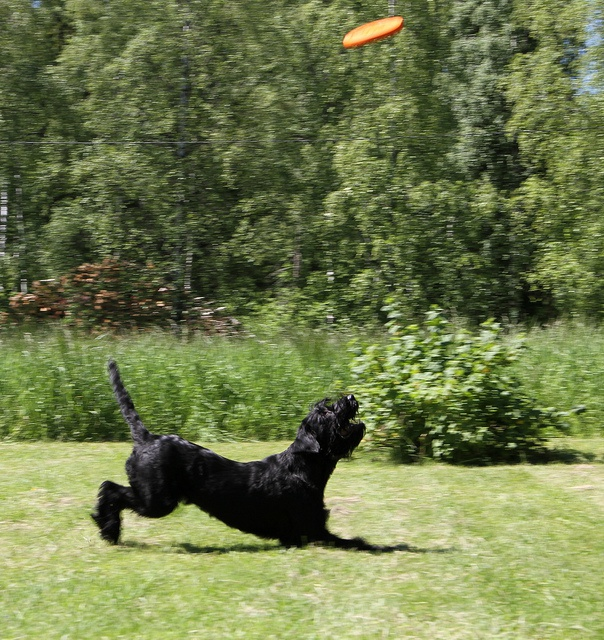Describe the objects in this image and their specific colors. I can see dog in gray, black, darkgreen, and darkgray tones and frisbee in gray, khaki, orange, and maroon tones in this image. 